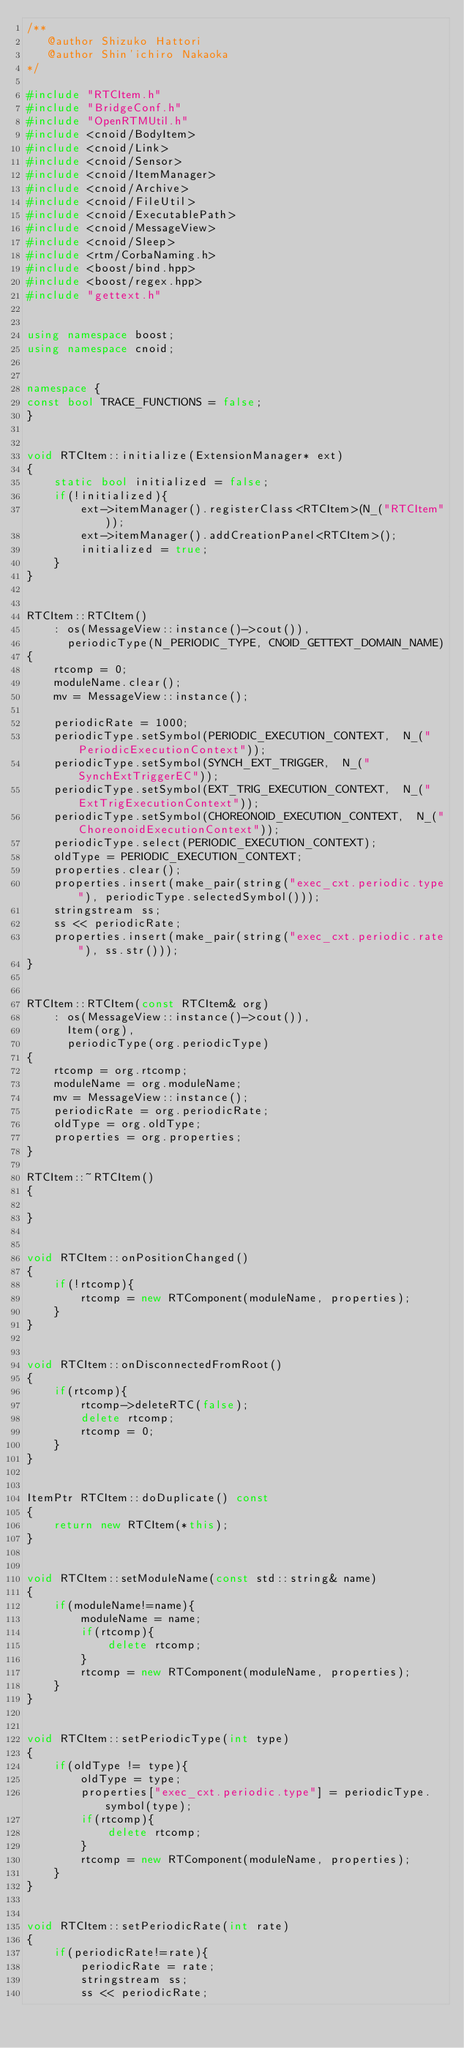Convert code to text. <code><loc_0><loc_0><loc_500><loc_500><_C++_>/**
   @author Shizuko Hattori
   @author Shin'ichiro Nakaoka
*/

#include "RTCItem.h"
#include "BridgeConf.h"
#include "OpenRTMUtil.h"
#include <cnoid/BodyItem>
#include <cnoid/Link>
#include <cnoid/Sensor>
#include <cnoid/ItemManager>
#include <cnoid/Archive>
#include <cnoid/FileUtil>
#include <cnoid/ExecutablePath>
#include <cnoid/MessageView>
#include <cnoid/Sleep>
#include <rtm/CorbaNaming.h>
#include <boost/bind.hpp>
#include <boost/regex.hpp>
#include "gettext.h"


using namespace boost;
using namespace cnoid;


namespace {
const bool TRACE_FUNCTIONS = false;
}


void RTCItem::initialize(ExtensionManager* ext)
{
    static bool initialized = false;
    if(!initialized){
        ext->itemManager().registerClass<RTCItem>(N_("RTCItem"));
        ext->itemManager().addCreationPanel<RTCItem>();
        initialized = true;
    }
}


RTCItem::RTCItem()
    : os(MessageView::instance()->cout()),
      periodicType(N_PERIODIC_TYPE, CNOID_GETTEXT_DOMAIN_NAME)
{
    rtcomp = 0;
    moduleName.clear();
    mv = MessageView::instance();

    periodicRate = 1000;
    periodicType.setSymbol(PERIODIC_EXECUTION_CONTEXT,  N_("PeriodicExecutionContext"));
    periodicType.setSymbol(SYNCH_EXT_TRIGGER,  N_("SynchExtTriggerEC"));
    periodicType.setSymbol(EXT_TRIG_EXECUTION_CONTEXT,  N_("ExtTrigExecutionContext"));
    periodicType.setSymbol(CHOREONOID_EXECUTION_CONTEXT,  N_("ChoreonoidExecutionContext"));
    periodicType.select(PERIODIC_EXECUTION_CONTEXT);
    oldType = PERIODIC_EXECUTION_CONTEXT;
    properties.clear();
    properties.insert(make_pair(string("exec_cxt.periodic.type"), periodicType.selectedSymbol()));
    stringstream ss;
    ss << periodicRate;
    properties.insert(make_pair(string("exec_cxt.periodic.rate"), ss.str()));
}


RTCItem::RTCItem(const RTCItem& org)
    : os(MessageView::instance()->cout()),
      Item(org),
      periodicType(org.periodicType)
{
    rtcomp = org.rtcomp;
    moduleName = org.moduleName;
    mv = MessageView::instance();
    periodicRate = org.periodicRate;
    oldType = org.oldType;
    properties = org.properties;
}

RTCItem::~RTCItem()
{
    
}


void RTCItem::onPositionChanged()
{
    if(!rtcomp){
        rtcomp = new RTComponent(moduleName, properties);
    }
}


void RTCItem::onDisconnectedFromRoot()
{
    if(rtcomp){
        rtcomp->deleteRTC(false);
        delete rtcomp;
        rtcomp = 0;
    }
}


ItemPtr RTCItem::doDuplicate() const
{
    return new RTCItem(*this);
}


void RTCItem::setModuleName(const std::string& name)
{
    if(moduleName!=name){
        moduleName = name;
        if(rtcomp){
            delete rtcomp;
        }
        rtcomp = new RTComponent(moduleName, properties);
    }
}


void RTCItem::setPeriodicType(int type)
{
    if(oldType != type){
        oldType = type;
        properties["exec_cxt.periodic.type"] = periodicType.symbol(type);
        if(rtcomp){
            delete rtcomp;
        }
        rtcomp = new RTComponent(moduleName, properties);
    }
}


void RTCItem::setPeriodicRate(int rate)
{
    if(periodicRate!=rate){
        periodicRate = rate;
        stringstream ss;
        ss << periodicRate;</code> 